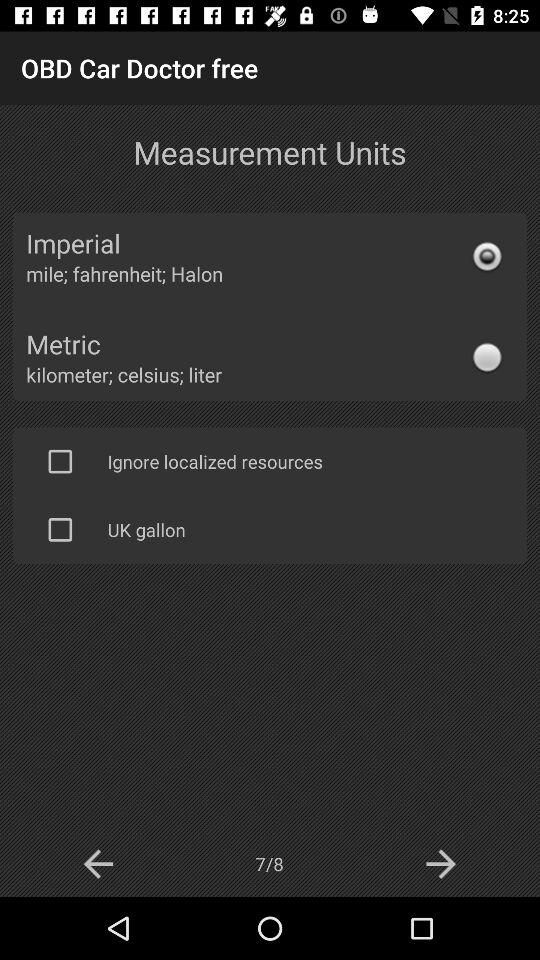How many pages in total are there? There are 8 pages in total. 